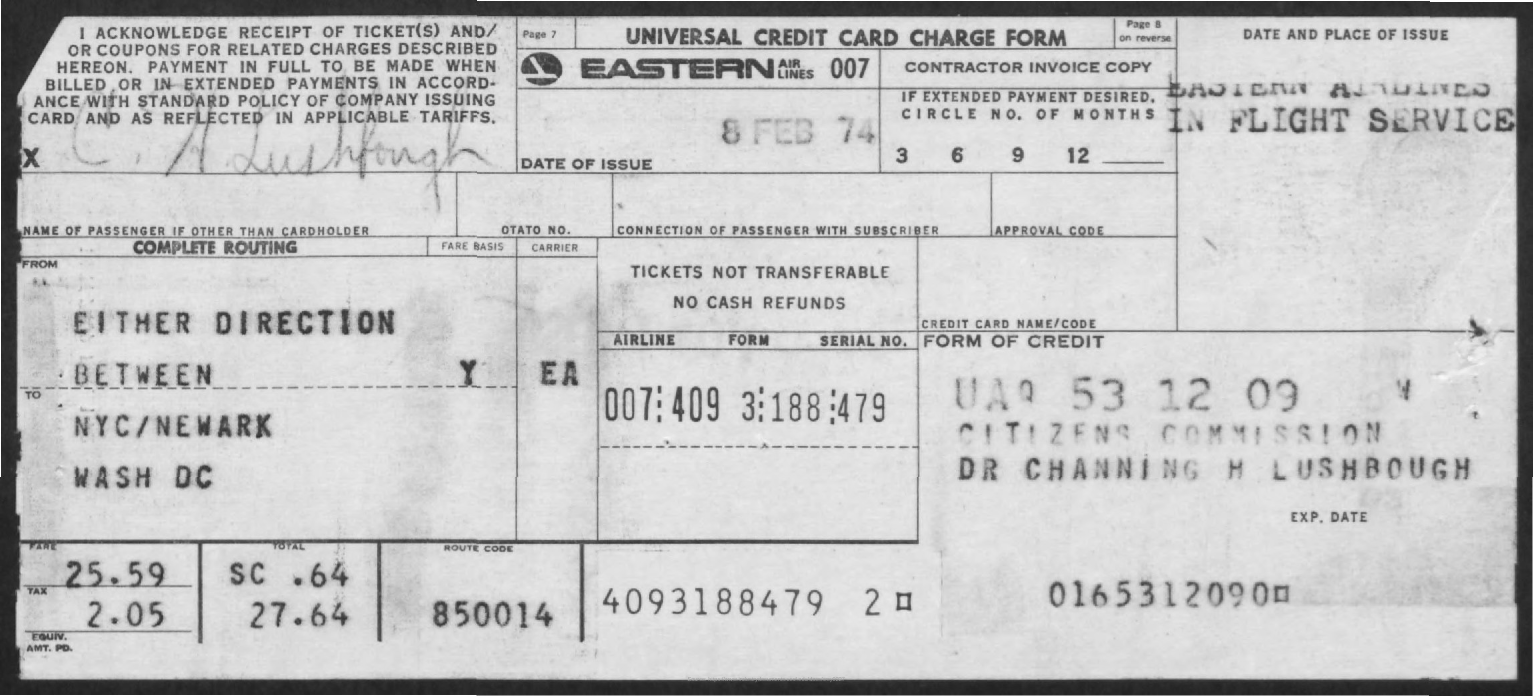What is the name of the form mentioned in the given page ?
Offer a very short reply. UNIVERSAL CREDIT CARD CHARGE FORM. What is the date of issue mentioned in the given form ?
Make the answer very short. 8 FEB 74. What is the amount of fine mentioned in the given form ?
Ensure brevity in your answer.  25.59. What is the amount of tax mentioned in the given form ?
Provide a succinct answer. 2.05. 